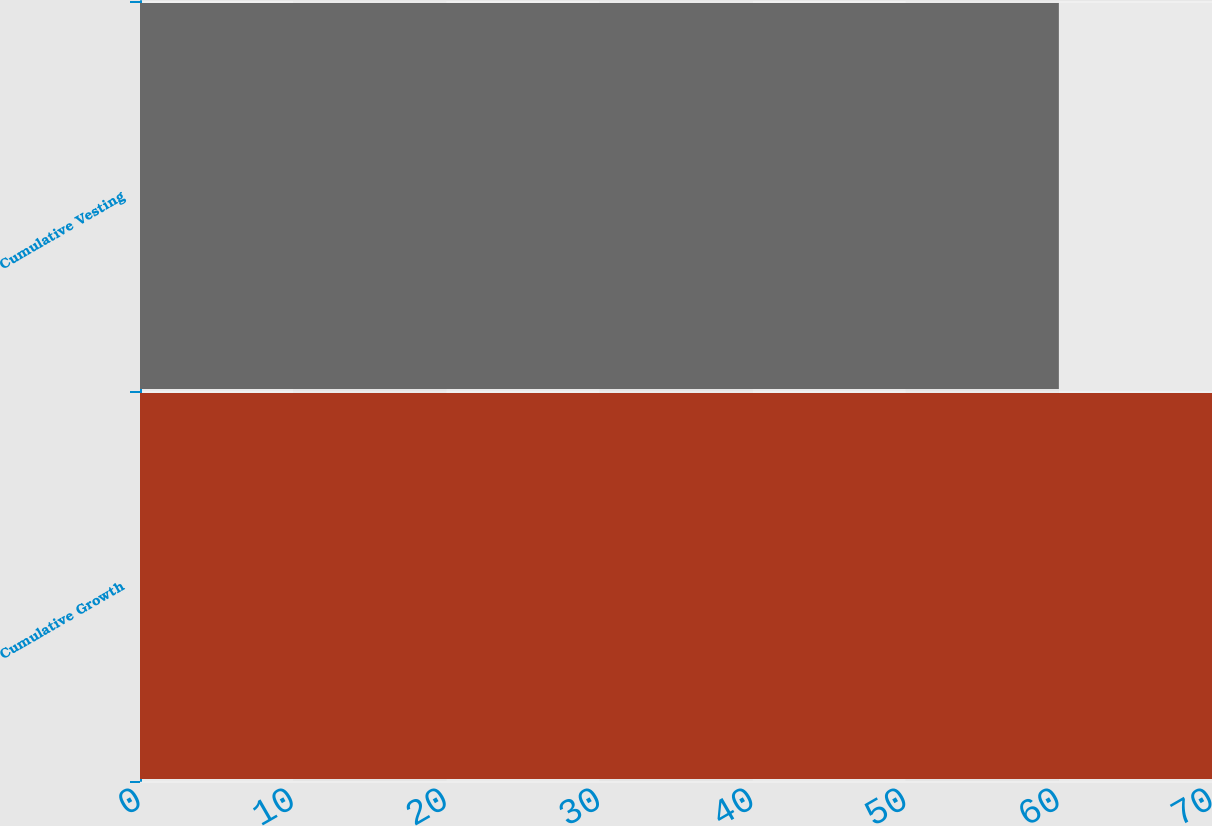<chart> <loc_0><loc_0><loc_500><loc_500><bar_chart><fcel>Cumulative Growth<fcel>Cumulative Vesting<nl><fcel>70<fcel>60<nl></chart> 